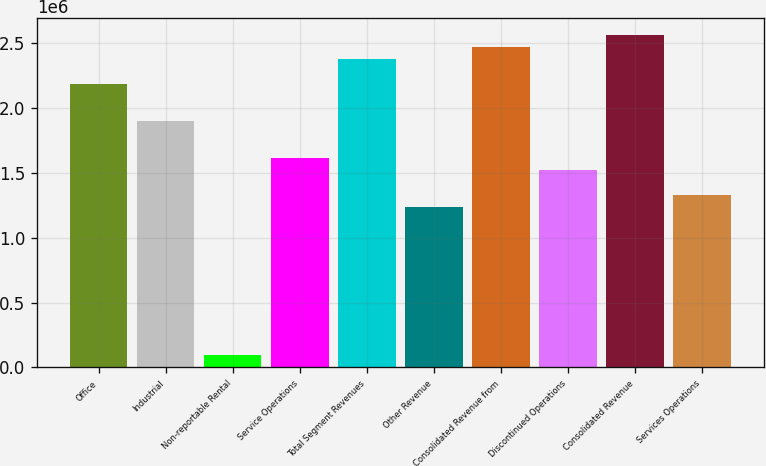Convert chart. <chart><loc_0><loc_0><loc_500><loc_500><bar_chart><fcel>Office<fcel>Industrial<fcel>Non-reportable Rental<fcel>Service Operations<fcel>Total Segment Revenues<fcel>Other Revenue<fcel>Consolidated Revenue from<fcel>Discontinued Operations<fcel>Consolidated Revenue<fcel>Services Operations<nl><fcel>2.18399e+06<fcel>1.89914e+06<fcel>95108.3<fcel>1.6143e+06<fcel>2.37389e+06<fcel>1.2345e+06<fcel>2.46884e+06<fcel>1.51935e+06<fcel>2.56379e+06<fcel>1.32945e+06<nl></chart> 